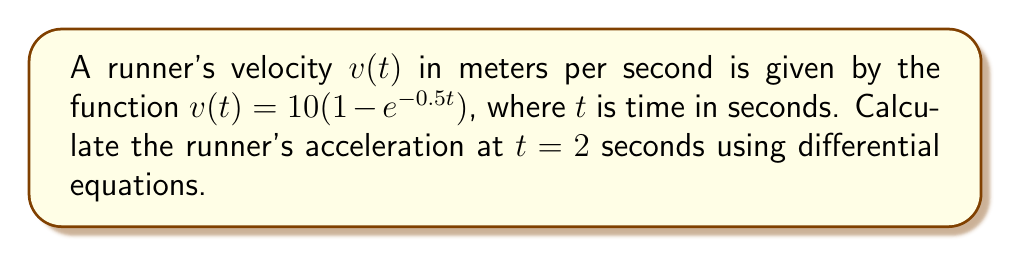Can you solve this math problem? To solve this problem, we'll follow these steps:

1) The acceleration is the derivative of velocity with respect to time. In mathematical terms:

   $a(t) = \frac{dv}{dt}$

2) We're given the velocity function:

   $v(t) = 10(1 - e^{-0.5t})$

3) To find the acceleration, we need to differentiate this function with respect to t:

   $\frac{d}{dt}[v(t)] = \frac{d}{dt}[10(1 - e^{-0.5t})]$

4) Using the chain rule:

   $a(t) = 10 \cdot \frac{d}{dt}[1 - e^{-0.5t}]$
   $a(t) = 10 \cdot (-1) \cdot (-0.5) \cdot e^{-0.5t}$
   $a(t) = 5e^{-0.5t}$

5) Now that we have the acceleration function, we can calculate the acceleration at t = 2 seconds:

   $a(2) = 5e^{-0.5(2)}$
   $a(2) = 5e^{-1}$

6) Evaluating this:

   $a(2) \approx 1.839$ m/s²

This acceleration is positive, indicating that the runner is still increasing speed at t = 2 seconds, albeit at a decreasing rate.
Answer: $5e^{-1}$ m/s² 